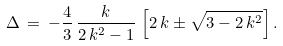Convert formula to latex. <formula><loc_0><loc_0><loc_500><loc_500>\Delta \, = \, - \frac { 4 } { 3 } \, \frac { k } { 2 \, k ^ { 2 } - 1 } \, \left [ 2 \, k \pm \sqrt { 3 - 2 \, k ^ { 2 } } \right ] .</formula> 